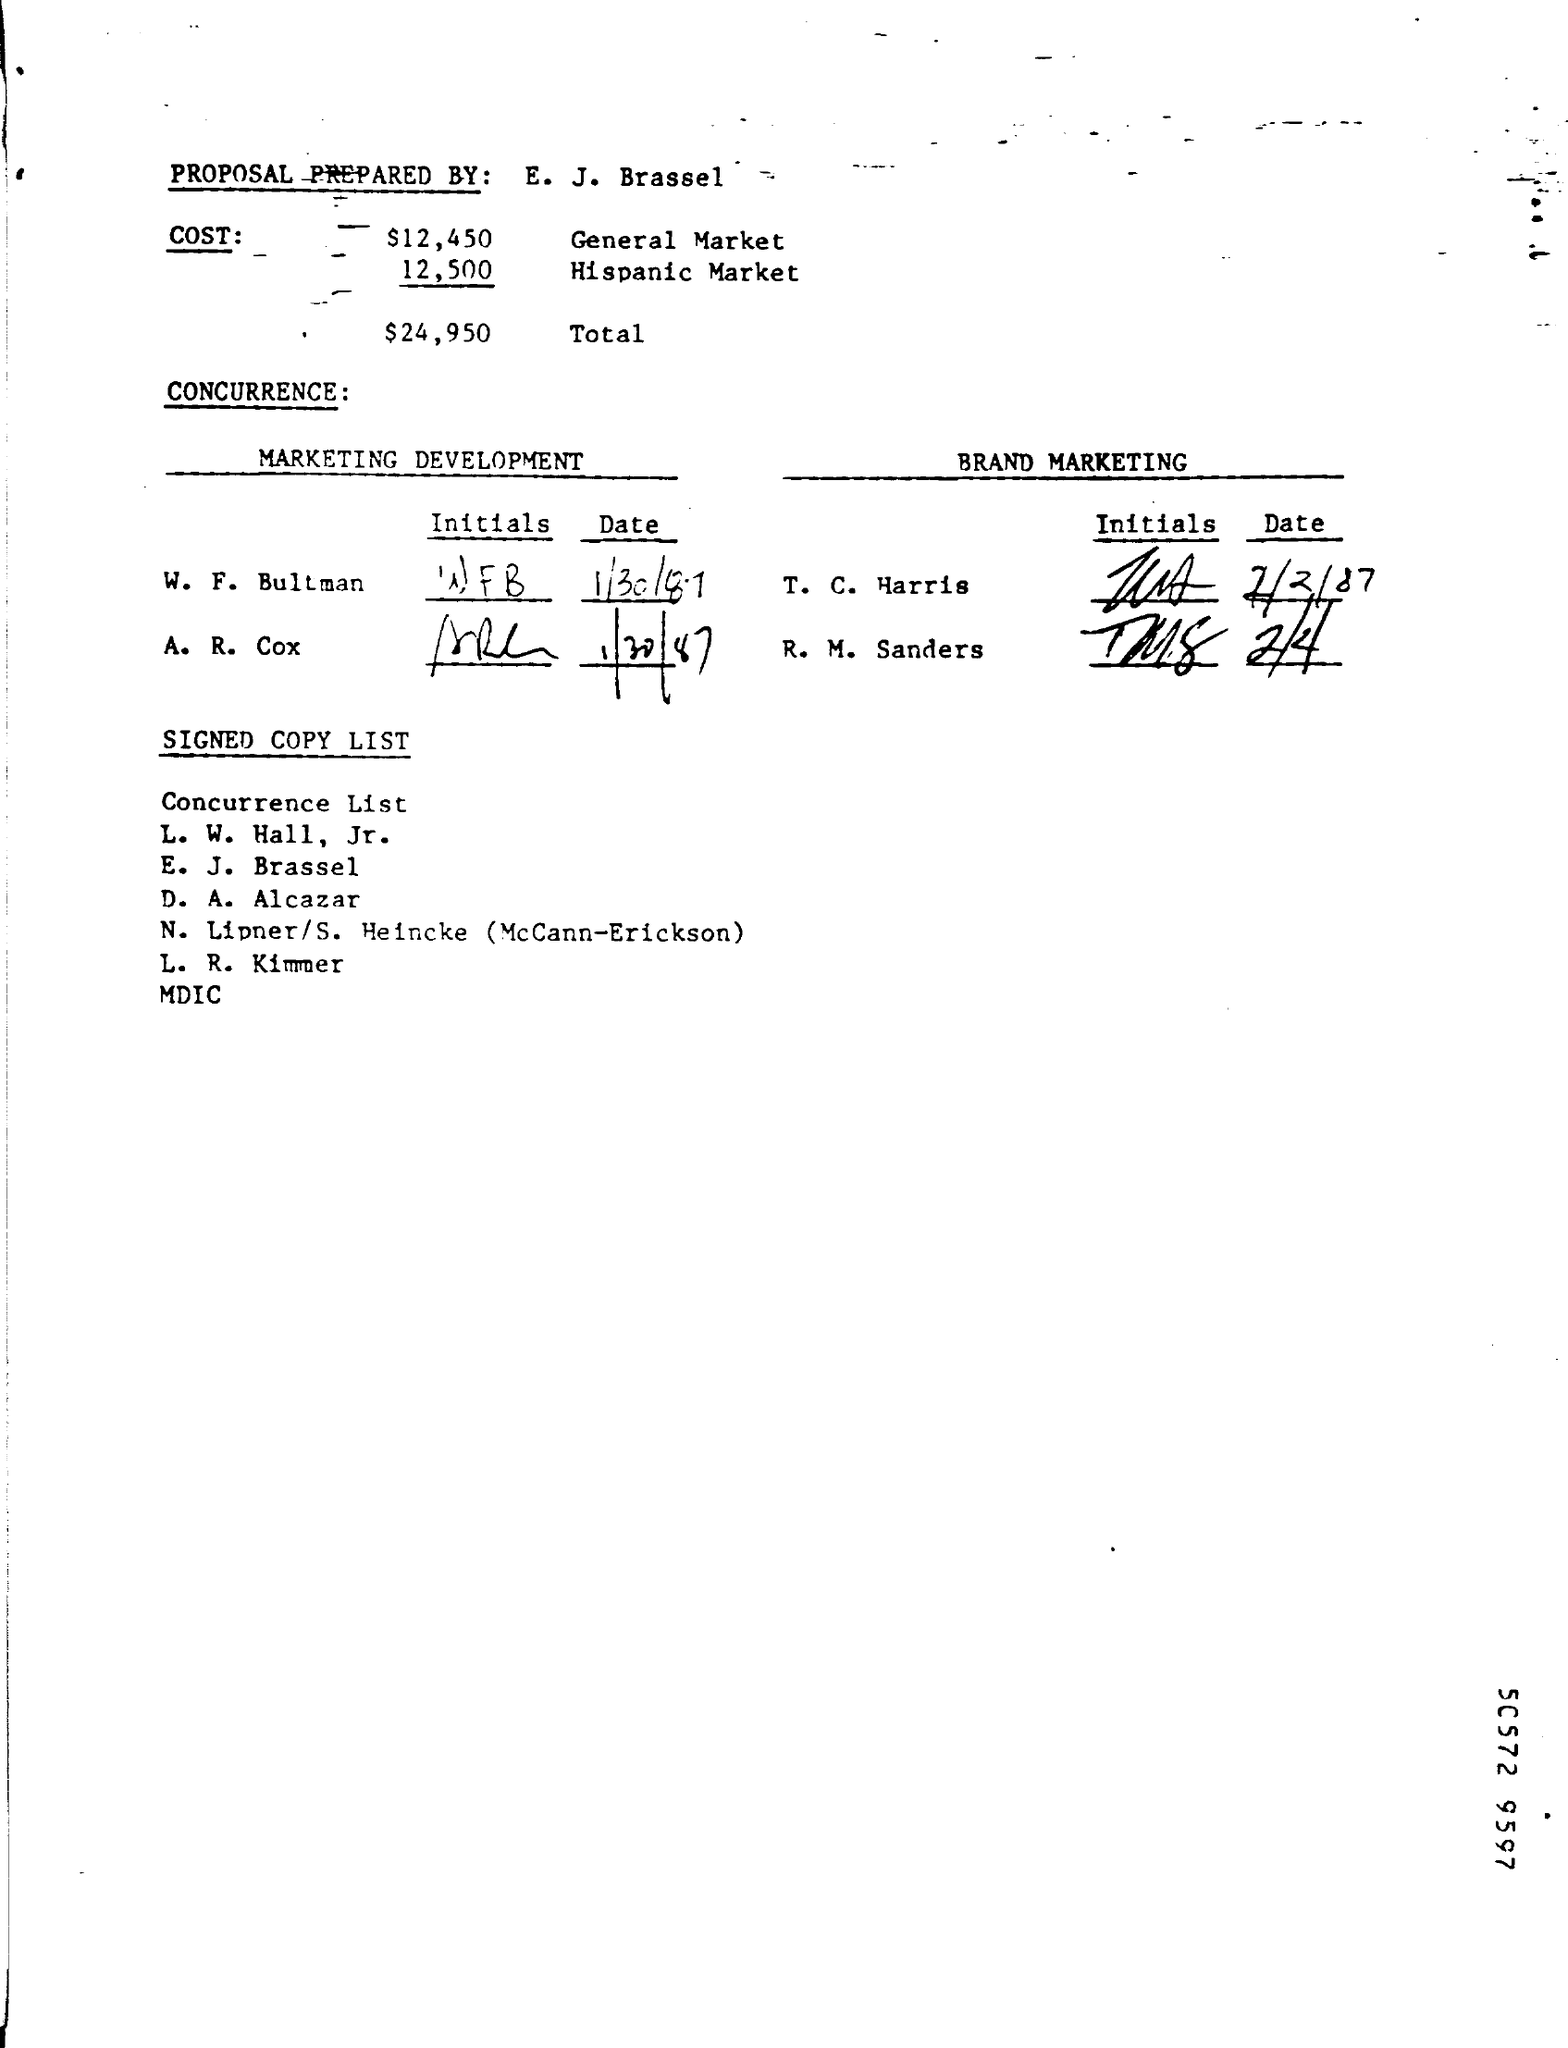Who prepared the PROPOSAL?
Your answer should be compact. E. J. Brassel. What is the Hispanic Market COST?
Provide a short and direct response. 12,500. Whats the date MARKETING DEVELOPMENT done by W. F. Bultman?
Your answer should be compact. 1/30/87. Whats Total COST in the PROPOSAL?
Provide a short and direct response. $24,950. 